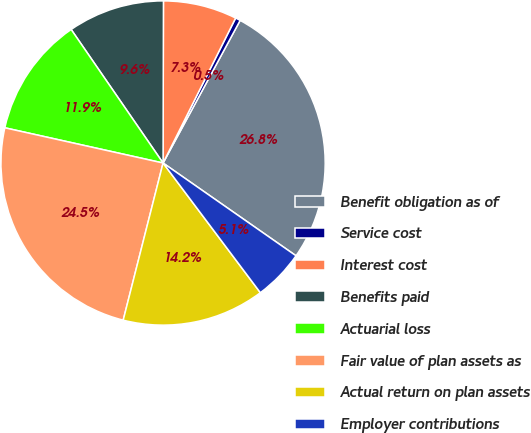Convert chart. <chart><loc_0><loc_0><loc_500><loc_500><pie_chart><fcel>Benefit obligation as of<fcel>Service cost<fcel>Interest cost<fcel>Benefits paid<fcel>Actuarial loss<fcel>Fair value of plan assets as<fcel>Actual return on plan assets<fcel>Employer contributions<nl><fcel>26.81%<fcel>0.5%<fcel>7.35%<fcel>9.63%<fcel>11.92%<fcel>24.53%<fcel>14.2%<fcel>5.06%<nl></chart> 